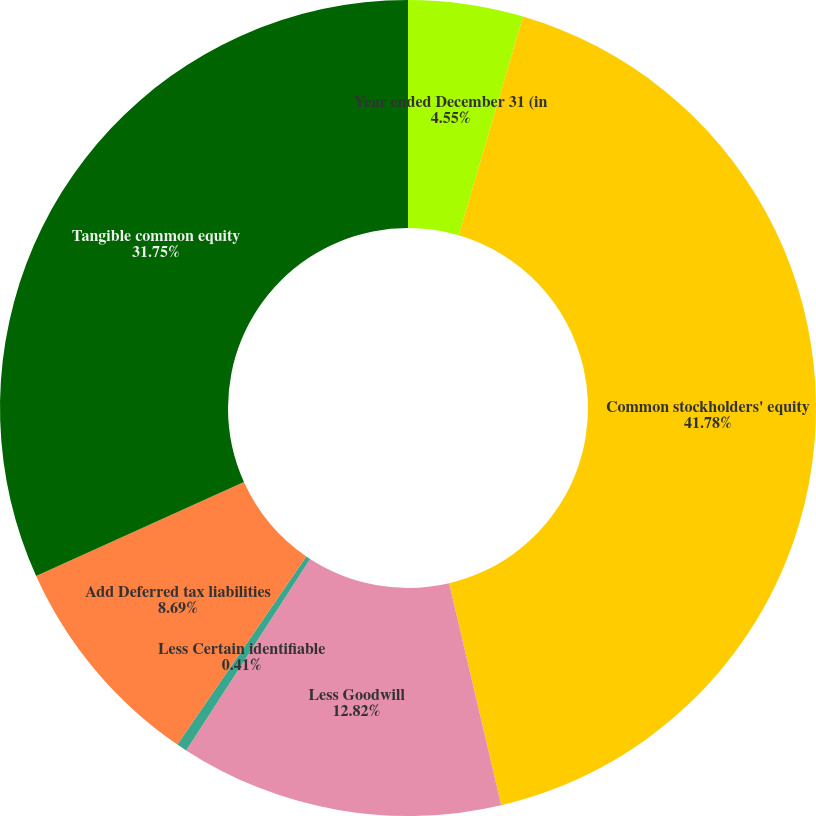<chart> <loc_0><loc_0><loc_500><loc_500><pie_chart><fcel>Year ended December 31 (in<fcel>Common stockholders' equity<fcel>Less Goodwill<fcel>Less Certain identifiable<fcel>Add Deferred tax liabilities<fcel>Tangible common equity<nl><fcel>4.55%<fcel>41.78%<fcel>12.82%<fcel>0.41%<fcel>8.69%<fcel>31.75%<nl></chart> 